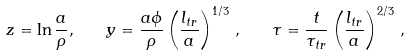<formula> <loc_0><loc_0><loc_500><loc_500>z = \ln \frac { a } { \rho } , \quad y = \frac { a \phi } { \rho } \left ( \frac { l _ { t r } } { a } \right ) ^ { 1 / 3 } \, , \quad \tau = \frac { t } { \tau _ { t r } } \left ( \frac { l _ { t r } } { a } \right ) ^ { 2 / 3 } \, ,</formula> 